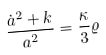Convert formula to latex. <formula><loc_0><loc_0><loc_500><loc_500>\frac { \dot { a } ^ { 2 } + k } { a ^ { 2 } } = \frac { \kappa } { 3 } \varrho</formula> 